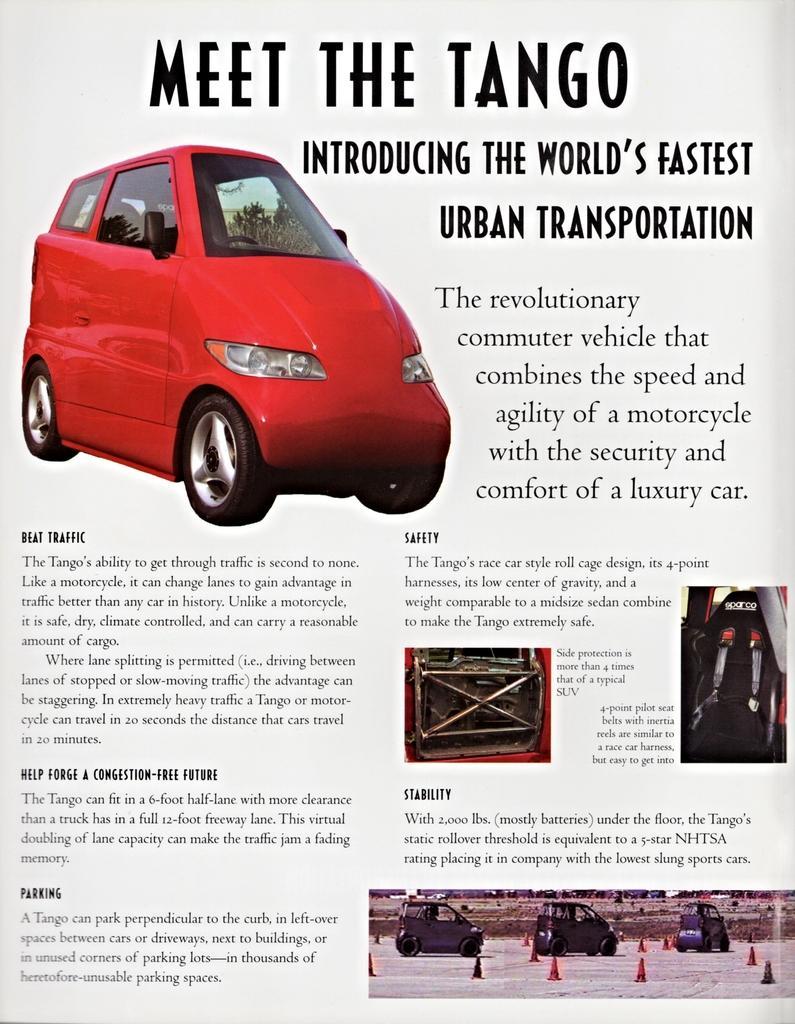Please provide a concise description of this image. In this image we can see a sheet, in which it describes about a car. The car name is tango. Whereas here car parts are explained in the sheet. 